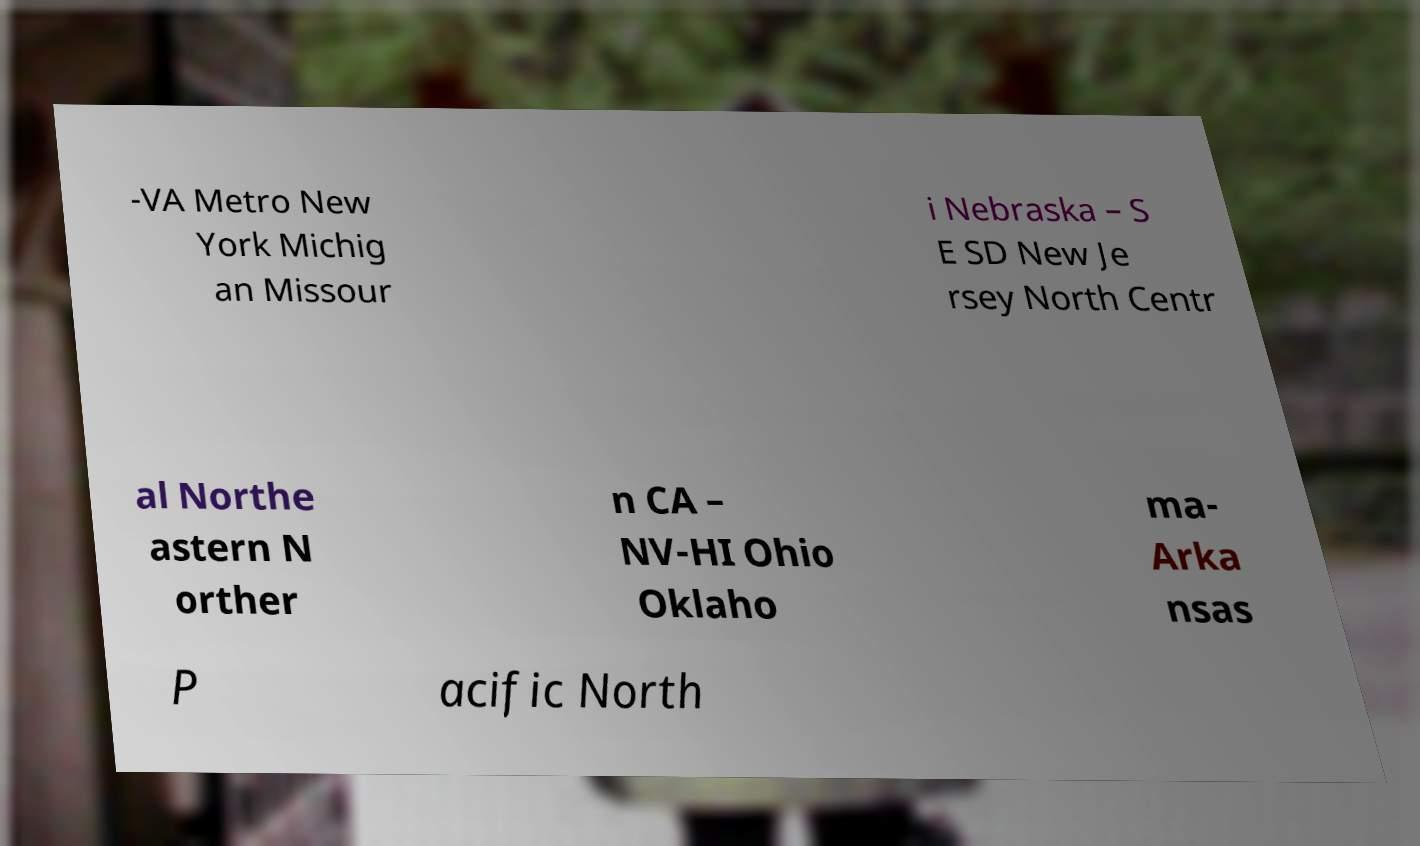Can you accurately transcribe the text from the provided image for me? -VA Metro New York Michig an Missour i Nebraska – S E SD New Je rsey North Centr al Northe astern N orther n CA – NV-HI Ohio Oklaho ma- Arka nsas P acific North 